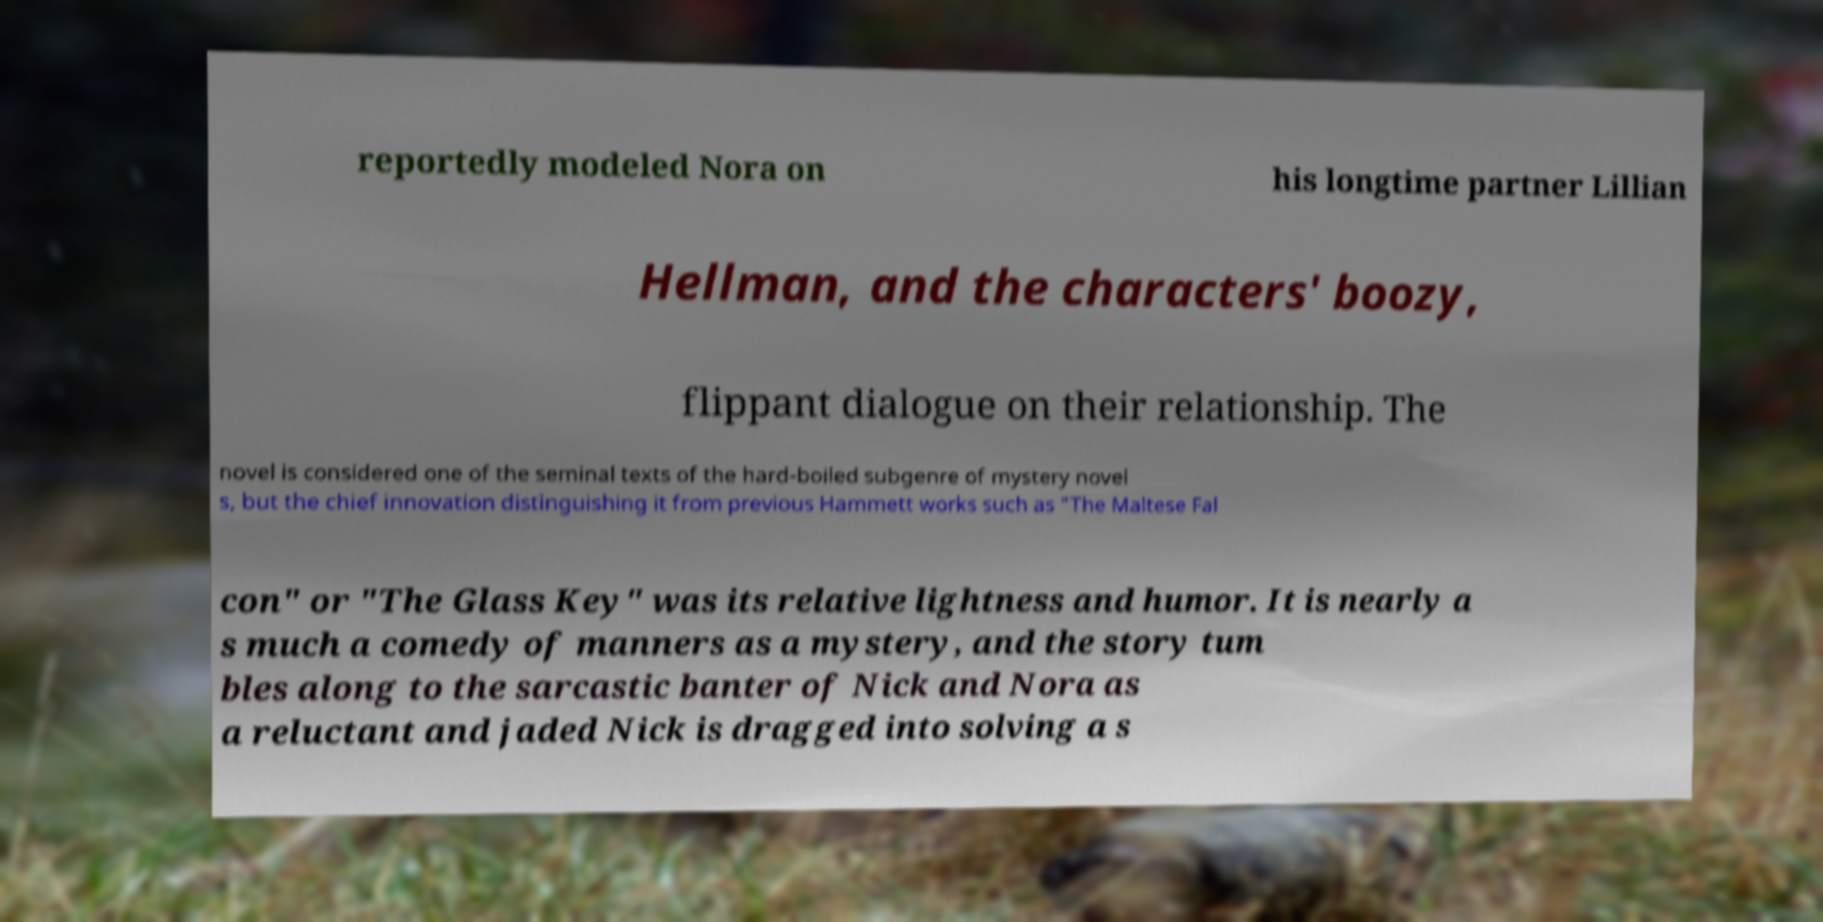For documentation purposes, I need the text within this image transcribed. Could you provide that? reportedly modeled Nora on his longtime partner Lillian Hellman, and the characters' boozy, flippant dialogue on their relationship. The novel is considered one of the seminal texts of the hard-boiled subgenre of mystery novel s, but the chief innovation distinguishing it from previous Hammett works such as "The Maltese Fal con" or "The Glass Key" was its relative lightness and humor. It is nearly a s much a comedy of manners as a mystery, and the story tum bles along to the sarcastic banter of Nick and Nora as a reluctant and jaded Nick is dragged into solving a s 